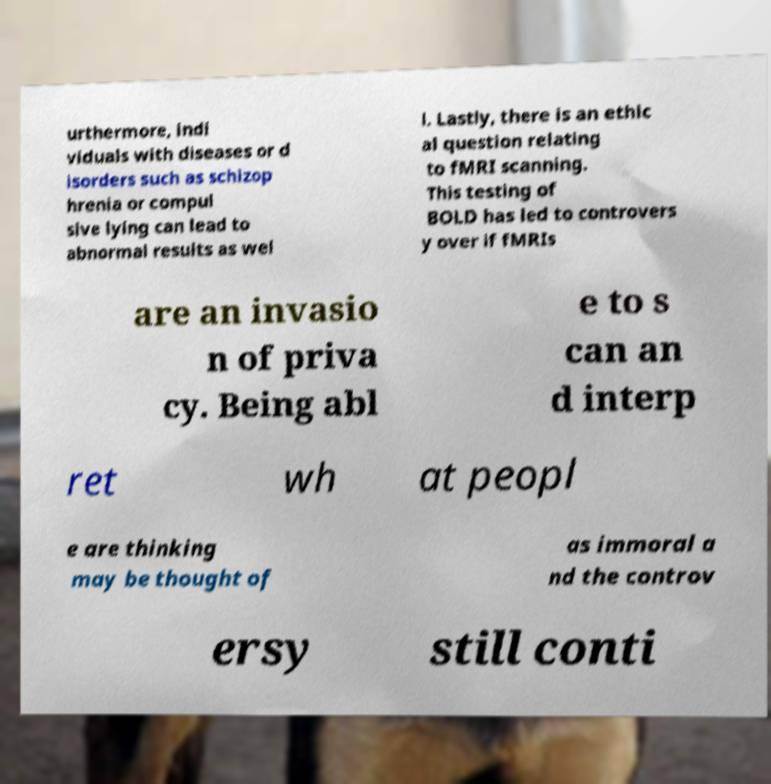Please read and relay the text visible in this image. What does it say? urthermore, indi viduals with diseases or d isorders such as schizop hrenia or compul sive lying can lead to abnormal results as wel l. Lastly, there is an ethic al question relating to fMRI scanning. This testing of BOLD has led to controvers y over if fMRIs are an invasio n of priva cy. Being abl e to s can an d interp ret wh at peopl e are thinking may be thought of as immoral a nd the controv ersy still conti 